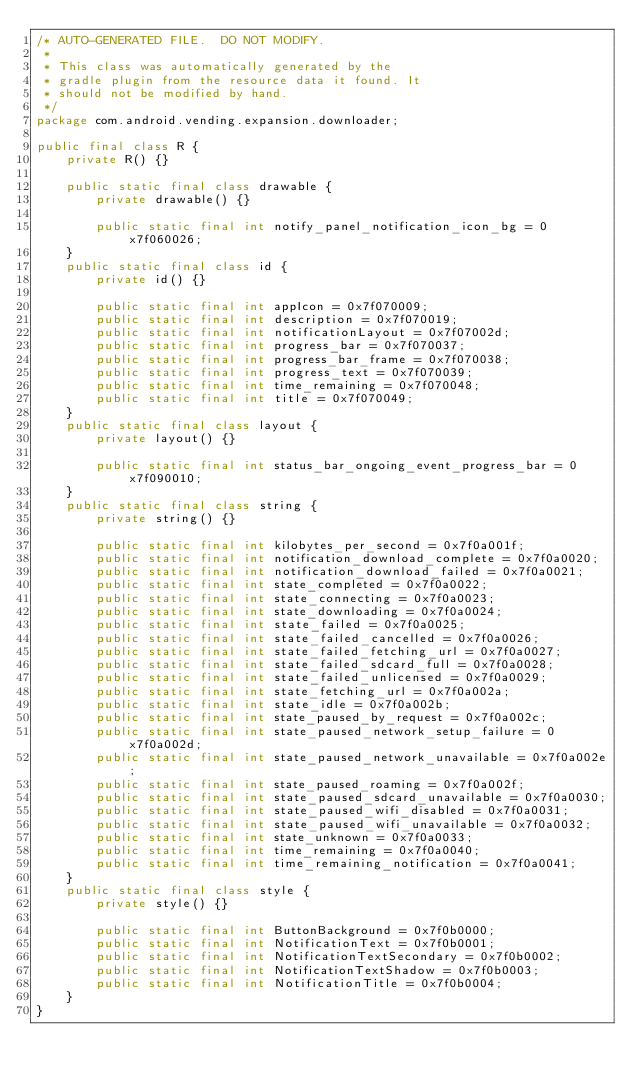<code> <loc_0><loc_0><loc_500><loc_500><_Java_>/* AUTO-GENERATED FILE.  DO NOT MODIFY.
 *
 * This class was automatically generated by the
 * gradle plugin from the resource data it found. It
 * should not be modified by hand.
 */
package com.android.vending.expansion.downloader;

public final class R {
    private R() {}

    public static final class drawable {
        private drawable() {}

        public static final int notify_panel_notification_icon_bg = 0x7f060026;
    }
    public static final class id {
        private id() {}

        public static final int appIcon = 0x7f070009;
        public static final int description = 0x7f070019;
        public static final int notificationLayout = 0x7f07002d;
        public static final int progress_bar = 0x7f070037;
        public static final int progress_bar_frame = 0x7f070038;
        public static final int progress_text = 0x7f070039;
        public static final int time_remaining = 0x7f070048;
        public static final int title = 0x7f070049;
    }
    public static final class layout {
        private layout() {}

        public static final int status_bar_ongoing_event_progress_bar = 0x7f090010;
    }
    public static final class string {
        private string() {}

        public static final int kilobytes_per_second = 0x7f0a001f;
        public static final int notification_download_complete = 0x7f0a0020;
        public static final int notification_download_failed = 0x7f0a0021;
        public static final int state_completed = 0x7f0a0022;
        public static final int state_connecting = 0x7f0a0023;
        public static final int state_downloading = 0x7f0a0024;
        public static final int state_failed = 0x7f0a0025;
        public static final int state_failed_cancelled = 0x7f0a0026;
        public static final int state_failed_fetching_url = 0x7f0a0027;
        public static final int state_failed_sdcard_full = 0x7f0a0028;
        public static final int state_failed_unlicensed = 0x7f0a0029;
        public static final int state_fetching_url = 0x7f0a002a;
        public static final int state_idle = 0x7f0a002b;
        public static final int state_paused_by_request = 0x7f0a002c;
        public static final int state_paused_network_setup_failure = 0x7f0a002d;
        public static final int state_paused_network_unavailable = 0x7f0a002e;
        public static final int state_paused_roaming = 0x7f0a002f;
        public static final int state_paused_sdcard_unavailable = 0x7f0a0030;
        public static final int state_paused_wifi_disabled = 0x7f0a0031;
        public static final int state_paused_wifi_unavailable = 0x7f0a0032;
        public static final int state_unknown = 0x7f0a0033;
        public static final int time_remaining = 0x7f0a0040;
        public static final int time_remaining_notification = 0x7f0a0041;
    }
    public static final class style {
        private style() {}

        public static final int ButtonBackground = 0x7f0b0000;
        public static final int NotificationText = 0x7f0b0001;
        public static final int NotificationTextSecondary = 0x7f0b0002;
        public static final int NotificationTextShadow = 0x7f0b0003;
        public static final int NotificationTitle = 0x7f0b0004;
    }
}
</code> 